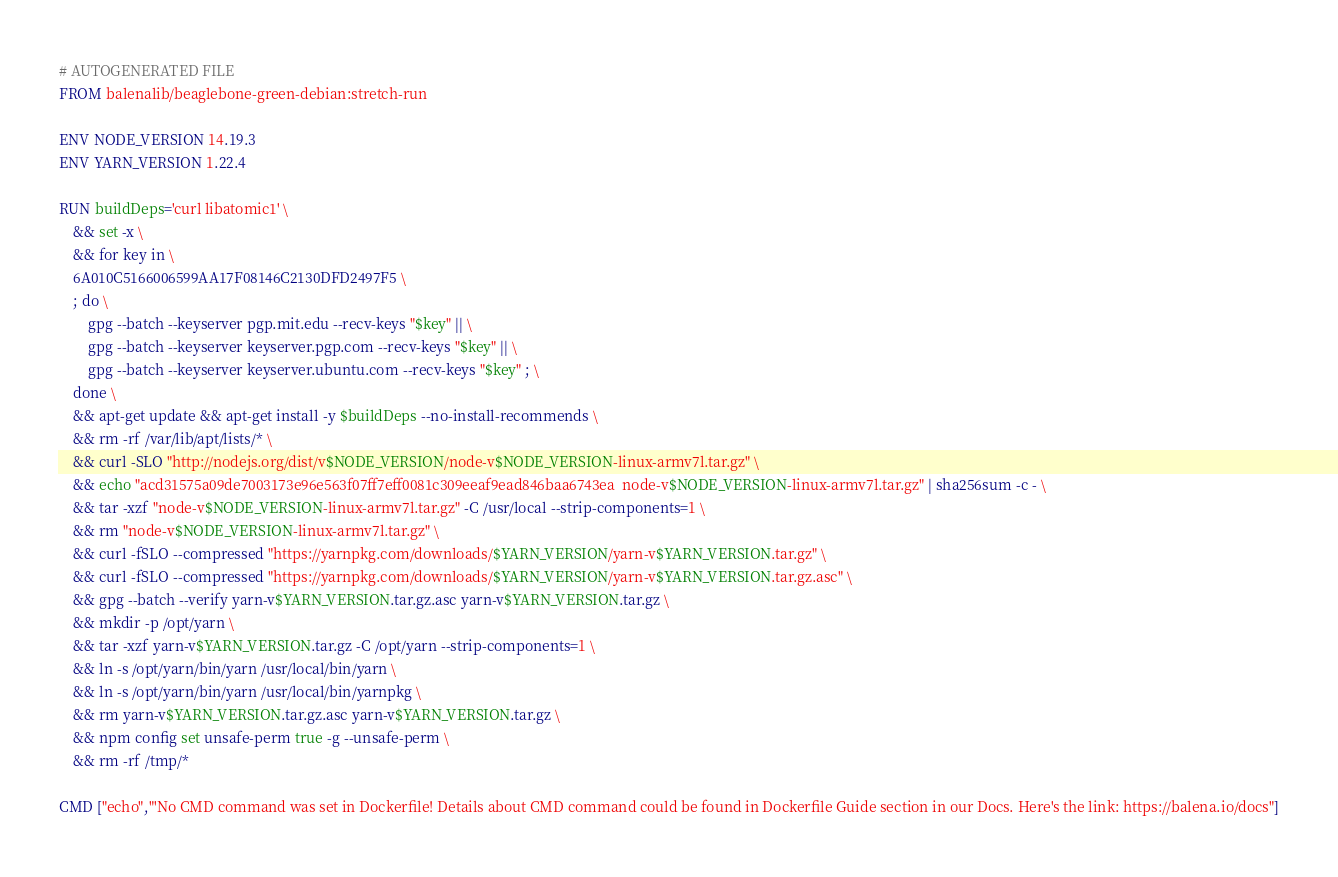<code> <loc_0><loc_0><loc_500><loc_500><_Dockerfile_># AUTOGENERATED FILE
FROM balenalib/beaglebone-green-debian:stretch-run

ENV NODE_VERSION 14.19.3
ENV YARN_VERSION 1.22.4

RUN buildDeps='curl libatomic1' \
	&& set -x \
	&& for key in \
	6A010C5166006599AA17F08146C2130DFD2497F5 \
	; do \
		gpg --batch --keyserver pgp.mit.edu --recv-keys "$key" || \
		gpg --batch --keyserver keyserver.pgp.com --recv-keys "$key" || \
		gpg --batch --keyserver keyserver.ubuntu.com --recv-keys "$key" ; \
	done \
	&& apt-get update && apt-get install -y $buildDeps --no-install-recommends \
	&& rm -rf /var/lib/apt/lists/* \
	&& curl -SLO "http://nodejs.org/dist/v$NODE_VERSION/node-v$NODE_VERSION-linux-armv7l.tar.gz" \
	&& echo "acd31575a09de7003173e96e563f07ff7eff0081c309eeaf9ead846baa6743ea  node-v$NODE_VERSION-linux-armv7l.tar.gz" | sha256sum -c - \
	&& tar -xzf "node-v$NODE_VERSION-linux-armv7l.tar.gz" -C /usr/local --strip-components=1 \
	&& rm "node-v$NODE_VERSION-linux-armv7l.tar.gz" \
	&& curl -fSLO --compressed "https://yarnpkg.com/downloads/$YARN_VERSION/yarn-v$YARN_VERSION.tar.gz" \
	&& curl -fSLO --compressed "https://yarnpkg.com/downloads/$YARN_VERSION/yarn-v$YARN_VERSION.tar.gz.asc" \
	&& gpg --batch --verify yarn-v$YARN_VERSION.tar.gz.asc yarn-v$YARN_VERSION.tar.gz \
	&& mkdir -p /opt/yarn \
	&& tar -xzf yarn-v$YARN_VERSION.tar.gz -C /opt/yarn --strip-components=1 \
	&& ln -s /opt/yarn/bin/yarn /usr/local/bin/yarn \
	&& ln -s /opt/yarn/bin/yarn /usr/local/bin/yarnpkg \
	&& rm yarn-v$YARN_VERSION.tar.gz.asc yarn-v$YARN_VERSION.tar.gz \
	&& npm config set unsafe-perm true -g --unsafe-perm \
	&& rm -rf /tmp/*

CMD ["echo","'No CMD command was set in Dockerfile! Details about CMD command could be found in Dockerfile Guide section in our Docs. Here's the link: https://balena.io/docs"]
</code> 